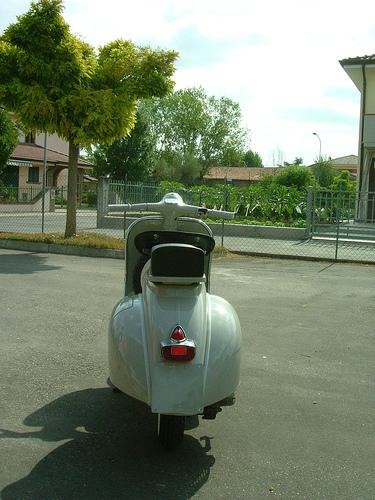What is the make and model of the vehicle in the image? While I cannot access specific data about the vehicle in the image, it appears to be a classic scooter resembling the style popular in the mid-20th century, possibly from a European manufacturer. 